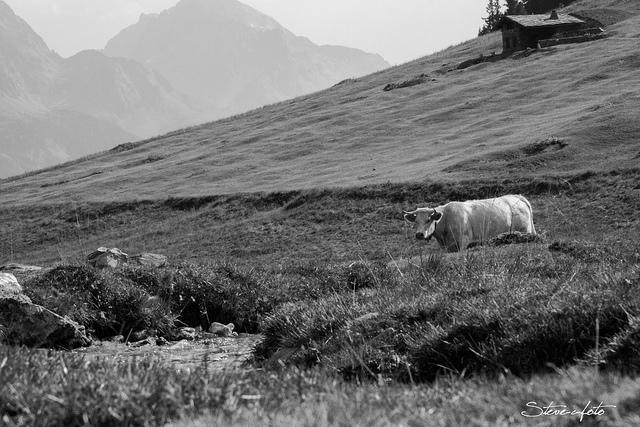How many legs does the animal have?
Give a very brief answer. 4. How many cows in the picture?
Give a very brief answer. 1. How many cow are white?
Give a very brief answer. 1. How many zebras are there in the picture?
Give a very brief answer. 0. 